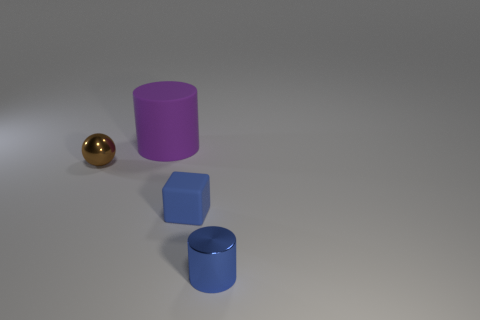Add 2 tiny blue rubber things. How many objects exist? 6 Subtract all blocks. How many objects are left? 3 Subtract all blocks. Subtract all small yellow rubber cubes. How many objects are left? 3 Add 4 blue rubber things. How many blue rubber things are left? 5 Add 3 large matte things. How many large matte things exist? 4 Subtract 0 gray cubes. How many objects are left? 4 